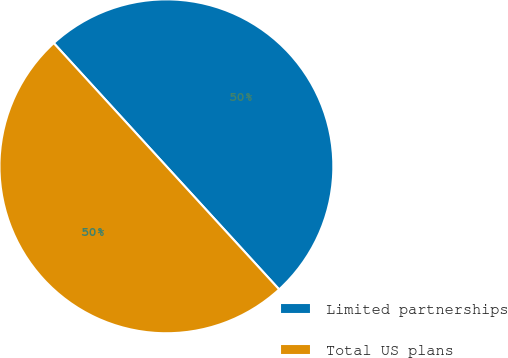Convert chart to OTSL. <chart><loc_0><loc_0><loc_500><loc_500><pie_chart><fcel>Limited partnerships<fcel>Total US plans<nl><fcel>49.99%<fcel>50.01%<nl></chart> 